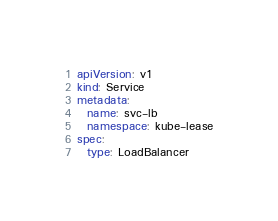Convert code to text. <code><loc_0><loc_0><loc_500><loc_500><_YAML_>apiVersion: v1
kind: Service
metadata:
  name: svc-lb
  namespace: kube-lease
spec:
  type: LoadBalancer
</code> 